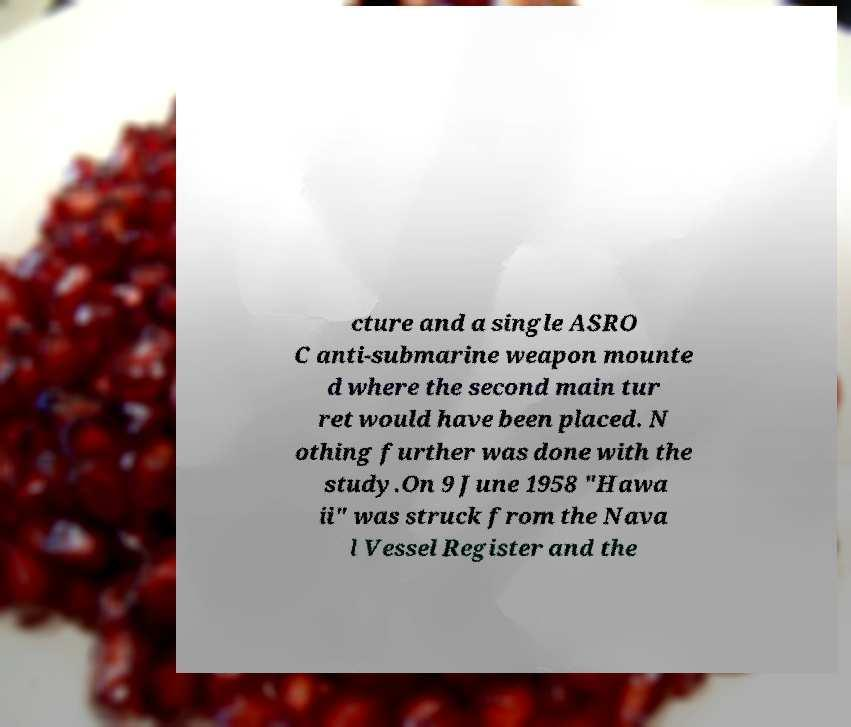Can you read and provide the text displayed in the image?This photo seems to have some interesting text. Can you extract and type it out for me? cture and a single ASRO C anti-submarine weapon mounte d where the second main tur ret would have been placed. N othing further was done with the study.On 9 June 1958 "Hawa ii" was struck from the Nava l Vessel Register and the 